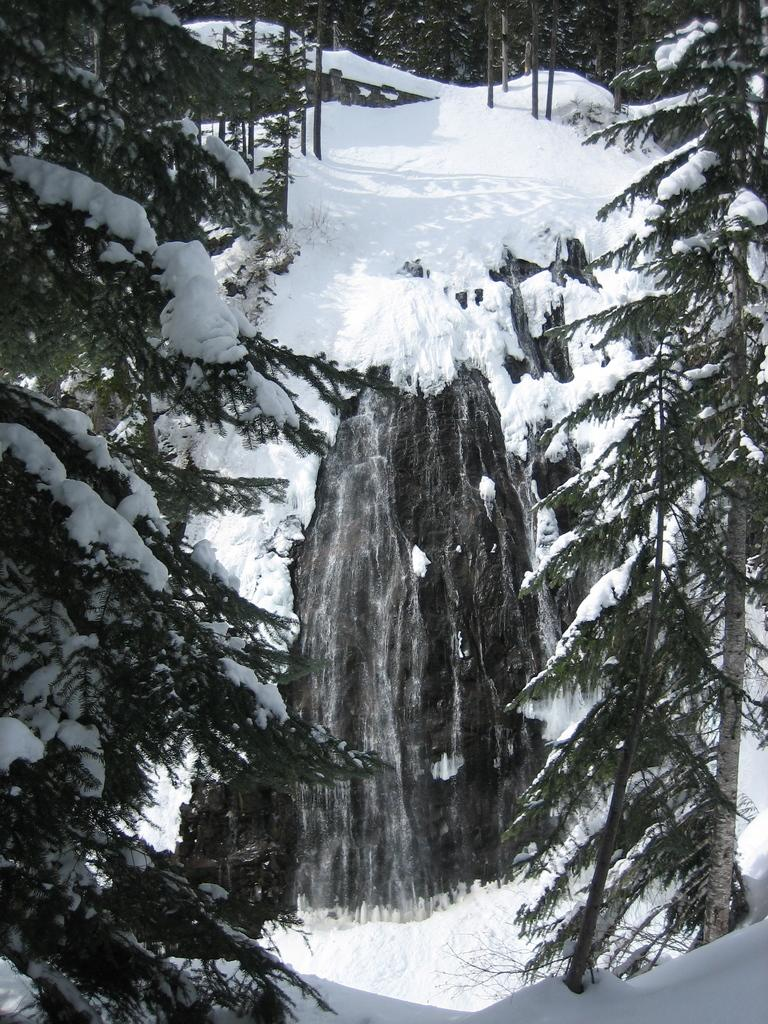What type of natural environment is depicted in the image? The image shows a snowy environment with trees and a rock covered in snow. Are the trees in the image covered with snow? Yes, there are trees covered with snow in the image. Can you describe the rock in the image? The rock in the image has snow on it. Are there any trees at the top of the image? Yes, there are trees at the top of the image, and they are also covered with snow. What type of coal can be seen in the image? There is no coal present in the image; it features a snowy environment with trees and a rock covered in snow. What does the image smell like? The image does not have a smell, as it is a visual representation. 